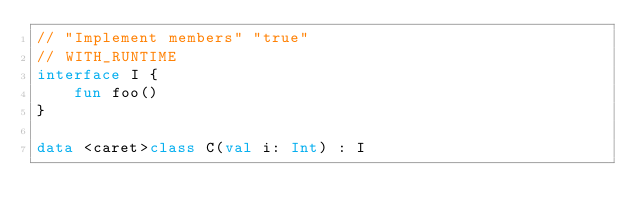Convert code to text. <code><loc_0><loc_0><loc_500><loc_500><_Kotlin_>// "Implement members" "true"
// WITH_RUNTIME
interface I {
    fun foo()
}

data <caret>class C(val i: Int) : I</code> 